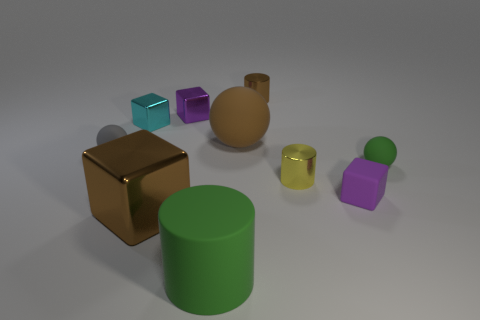Is there anything else that has the same size as the gray object?
Keep it short and to the point. Yes. The tiny matte ball that is to the left of the small sphere to the right of the brown metallic cube is what color?
Ensure brevity in your answer.  Gray. There is a green object that is to the left of the small shiny object that is in front of the green object behind the big cube; what shape is it?
Offer a terse response. Cylinder. What size is the ball that is on the right side of the tiny cyan object and on the left side of the small green thing?
Your answer should be very brief. Large. How many other small cubes have the same color as the rubber block?
Give a very brief answer. 1. There is a object that is the same color as the big rubber cylinder; what material is it?
Keep it short and to the point. Rubber. What is the material of the green ball?
Provide a short and direct response. Rubber. Does the tiny purple cube behind the small purple rubber block have the same material as the gray ball?
Provide a short and direct response. No. What is the shape of the tiny metal object that is on the left side of the large shiny cube?
Keep it short and to the point. Cube. What is the material of the yellow thing that is the same size as the gray thing?
Provide a succinct answer. Metal. 